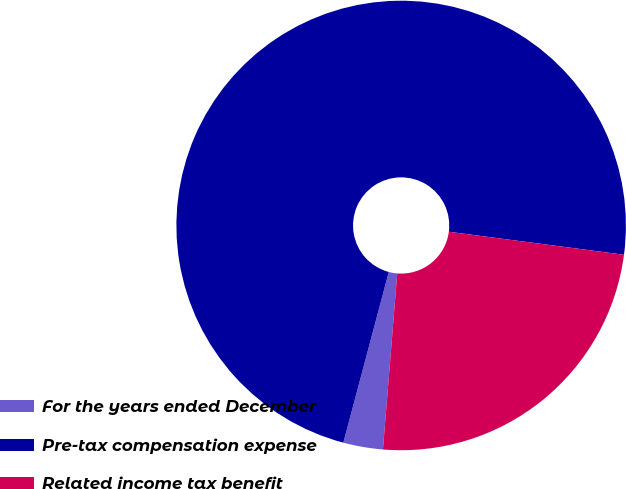Convert chart to OTSL. <chart><loc_0><loc_0><loc_500><loc_500><pie_chart><fcel>For the years ended December<fcel>Pre-tax compensation expense<fcel>Related income tax benefit<nl><fcel>2.85%<fcel>72.93%<fcel>24.21%<nl></chart> 